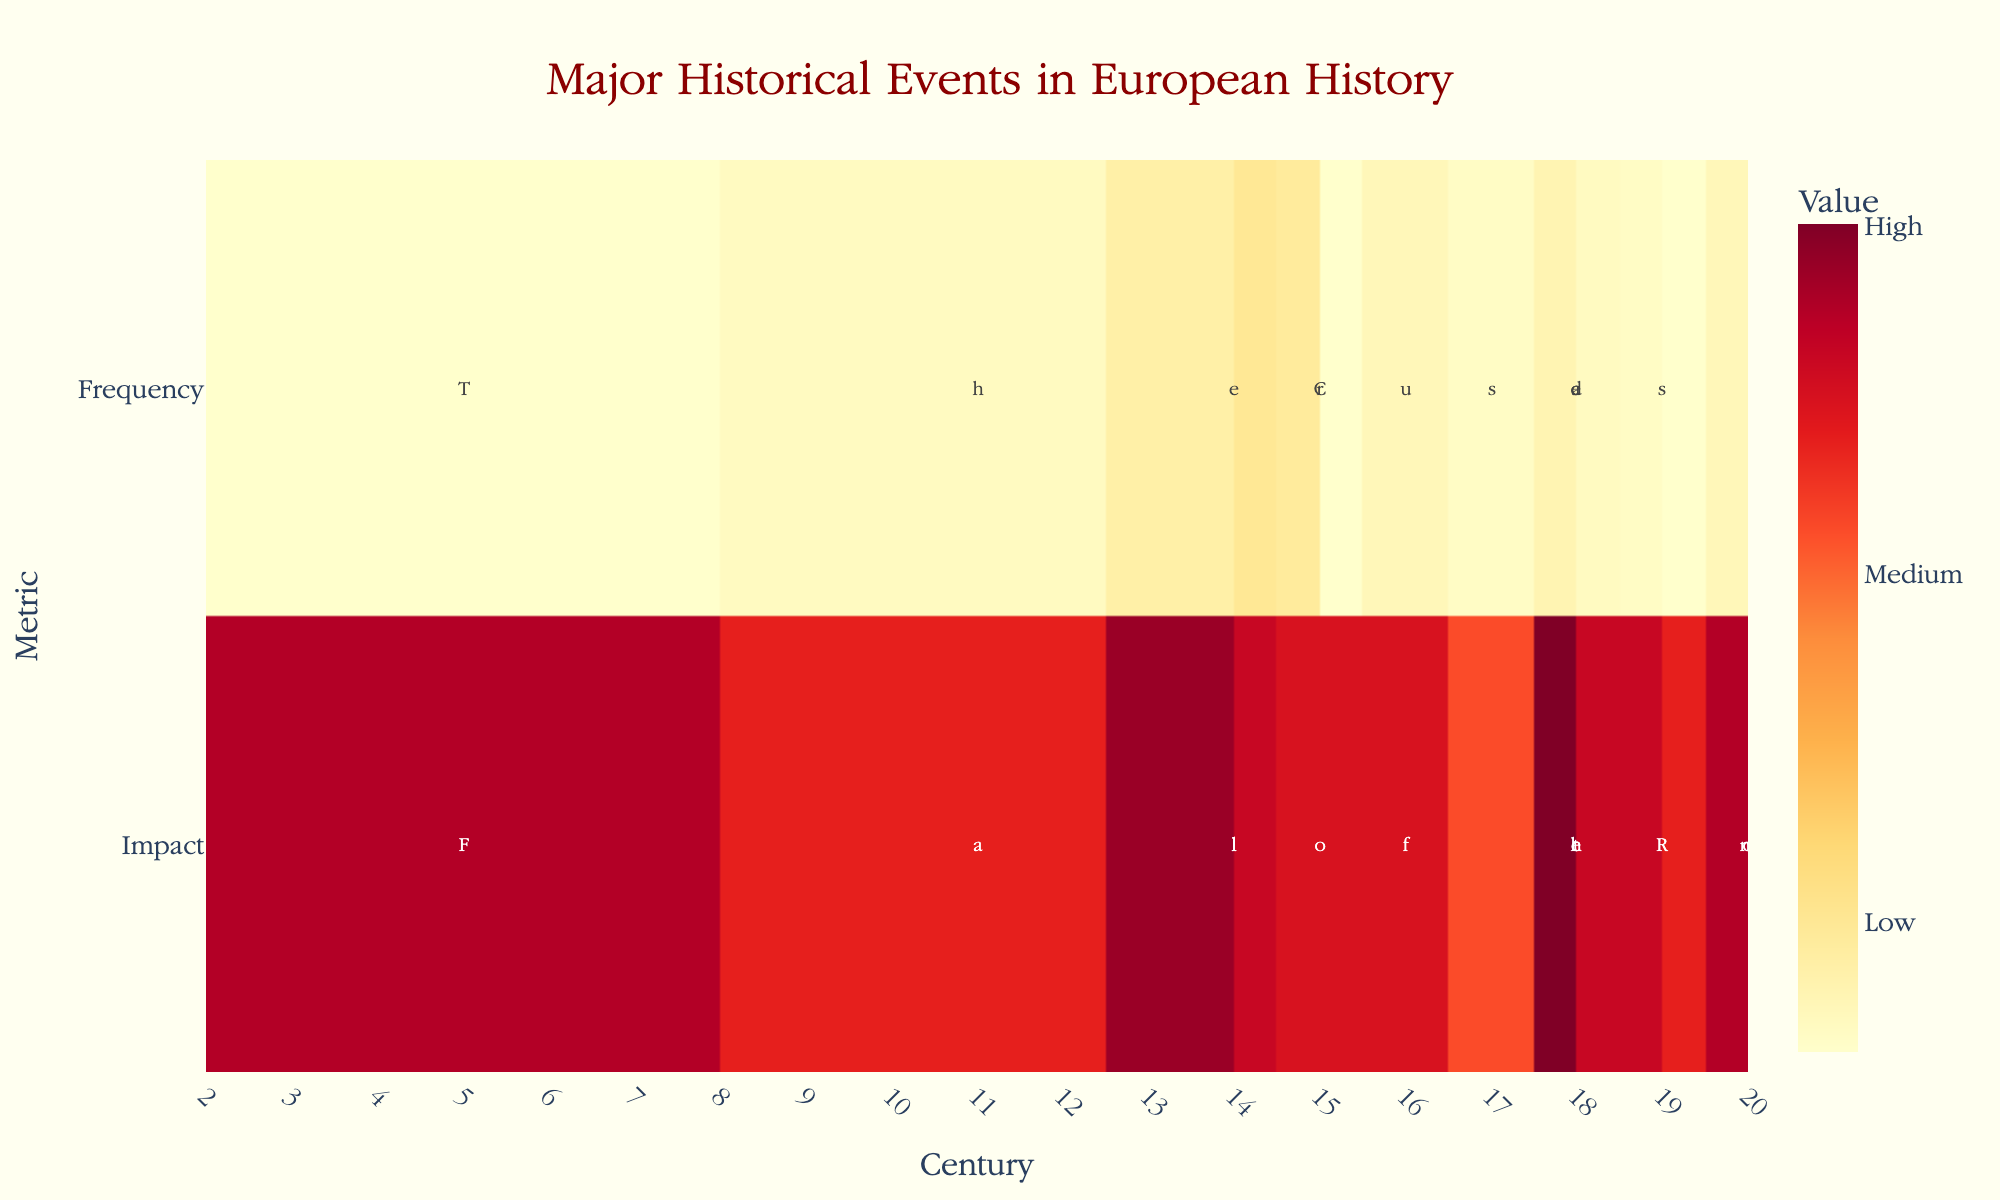What is the title of the heatmap? The title of the heatmap is located at the top center of the figure. According to the provided code, the title is "Major Historical Events in European History".
Answer: Major Historical Events in European History Which century has the highest frequency of events? To find this, we check the 'Frequency' row across all centuries and identify the highest value, which is 20. This corresponds to the 14th Century to 17th Century for the Renaissance.
Answer: 14th Century to 17th Century Which event has the highest estimated impact? In the 'Impact' row, find the highest value, which is 100. This corresponds to the 'Industrial Revolution' and 'World War II'.
Answer: Industrial Revolution, World War II What is the total estimated impact of events in the 18th Century? Locate the 'Impact' values for events in the 18th Century: Industrial Revolution (100), The Enlightenment (70), and French Revolution (85). Sum these values: 100 + 70 + 85 = 255.
Answer: 255 How does the frequency of 'World War I' compare to 'World War II'? Look at the 'Frequency' values for both World Wars; each has a frequency of 10.
Answer: Equal Which century has the lowest impact on average? Calculate the average 'Impact' value for each century and identify the lowest. For simplicity, examine visible values: 11th Century to 13th Century (75) has the lowest standalone value.
Answer: 11th Century to 13th Century How does the frequency of the Renaissance compare to the Black Death? The Renaissance has a 'Frequency' of 20, while the Black Death has a 'Frequency' of 15. Since 20 is greater than 15, the Renaissance occurred more frequently.
Answer: Renaissance is more frequent Do events in the 19th Century generally have higher impact or frequency? Compare 'Impact' and 'Frequency' values for 19th Century events: Napoleonic Wars (Impact: 85, Frequency: 7), Congress of Vienna (Impact: 75, Frequency: 5). Several events have a higher cumulative 'Impact' value (160) than 'Frequency' value (12).
Answer: Higher impact What's the average frequency of events in the 14th Century? For the 14th Century: Fall of the Roman Empire and Black Death have 'Frequency' 5 and 15, respectively. Average = (5 + 15) / 2 = 10.
Answer: 10 Which event had a higher impact: The Renaissance or The Enlightenment? Compare 'Impact' values: The Renaissance (85), The Enlightenment (70). The Renaissance has a higher impact.
Answer: The Renaissance 